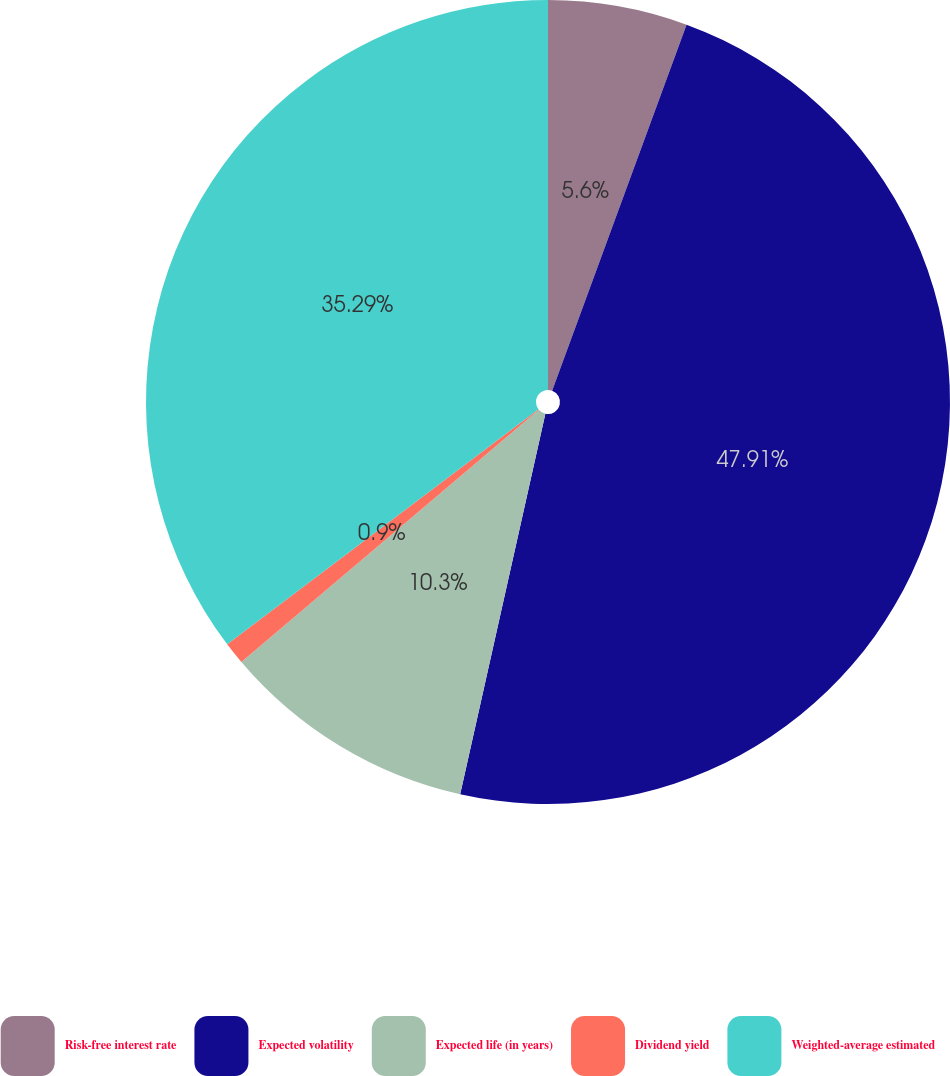Convert chart to OTSL. <chart><loc_0><loc_0><loc_500><loc_500><pie_chart><fcel>Risk-free interest rate<fcel>Expected volatility<fcel>Expected life (in years)<fcel>Dividend yield<fcel>Weighted-average estimated<nl><fcel>5.6%<fcel>47.9%<fcel>10.3%<fcel>0.9%<fcel>35.29%<nl></chart> 